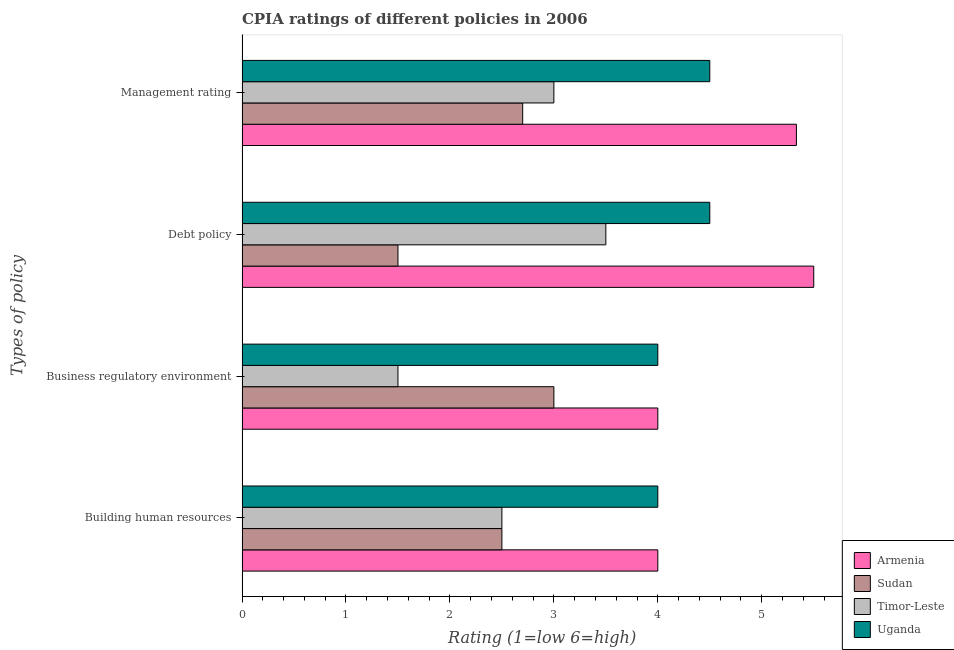How many different coloured bars are there?
Your answer should be very brief. 4. How many groups of bars are there?
Provide a succinct answer. 4. How many bars are there on the 1st tick from the top?
Offer a very short reply. 4. How many bars are there on the 1st tick from the bottom?
Give a very brief answer. 4. What is the label of the 4th group of bars from the top?
Offer a terse response. Building human resources. In which country was the cpia rating of debt policy maximum?
Ensure brevity in your answer.  Armenia. In which country was the cpia rating of building human resources minimum?
Your answer should be very brief. Sudan. What is the total cpia rating of debt policy in the graph?
Your response must be concise. 15. What is the difference between the cpia rating of management in Sudan and that in Uganda?
Your response must be concise. -1.8. What is the difference between the cpia rating of building human resources in Armenia and the cpia rating of business regulatory environment in Uganda?
Your answer should be compact. 0. What is the average cpia rating of debt policy per country?
Make the answer very short. 3.75. What is the difference between the cpia rating of debt policy and cpia rating of business regulatory environment in Armenia?
Offer a very short reply. 1.5. In how many countries, is the cpia rating of management greater than 2 ?
Provide a succinct answer. 4. What is the ratio of the cpia rating of debt policy in Uganda to that in Armenia?
Provide a short and direct response. 0.82. Is the difference between the cpia rating of management in Uganda and Sudan greater than the difference between the cpia rating of building human resources in Uganda and Sudan?
Make the answer very short. Yes. What is the difference between the highest and the second highest cpia rating of business regulatory environment?
Your answer should be very brief. 0. What is the difference between the highest and the lowest cpia rating of management?
Your response must be concise. 2.63. In how many countries, is the cpia rating of management greater than the average cpia rating of management taken over all countries?
Offer a very short reply. 2. What does the 4th bar from the top in Business regulatory environment represents?
Make the answer very short. Armenia. What does the 1st bar from the bottom in Debt policy represents?
Offer a very short reply. Armenia. Is it the case that in every country, the sum of the cpia rating of building human resources and cpia rating of business regulatory environment is greater than the cpia rating of debt policy?
Provide a succinct answer. Yes. How many bars are there?
Ensure brevity in your answer.  16. Are all the bars in the graph horizontal?
Provide a short and direct response. Yes. Does the graph contain grids?
Keep it short and to the point. No. Where does the legend appear in the graph?
Provide a succinct answer. Bottom right. What is the title of the graph?
Ensure brevity in your answer.  CPIA ratings of different policies in 2006. What is the label or title of the Y-axis?
Your answer should be compact. Types of policy. What is the Rating (1=low 6=high) in Sudan in Building human resources?
Provide a succinct answer. 2.5. What is the Rating (1=low 6=high) in Timor-Leste in Building human resources?
Give a very brief answer. 2.5. What is the Rating (1=low 6=high) of Armenia in Debt policy?
Make the answer very short. 5.5. What is the Rating (1=low 6=high) in Timor-Leste in Debt policy?
Make the answer very short. 3.5. What is the Rating (1=low 6=high) of Uganda in Debt policy?
Provide a succinct answer. 4.5. What is the Rating (1=low 6=high) in Armenia in Management rating?
Provide a short and direct response. 5.33. What is the Rating (1=low 6=high) in Sudan in Management rating?
Make the answer very short. 2.7. What is the Rating (1=low 6=high) in Uganda in Management rating?
Your answer should be very brief. 4.5. Across all Types of policy, what is the maximum Rating (1=low 6=high) in Sudan?
Your response must be concise. 3. Across all Types of policy, what is the maximum Rating (1=low 6=high) of Uganda?
Offer a very short reply. 4.5. Across all Types of policy, what is the minimum Rating (1=low 6=high) in Sudan?
Offer a very short reply. 1.5. What is the total Rating (1=low 6=high) in Armenia in the graph?
Your answer should be very brief. 18.83. What is the total Rating (1=low 6=high) of Uganda in the graph?
Offer a very short reply. 17. What is the difference between the Rating (1=low 6=high) of Armenia in Building human resources and that in Business regulatory environment?
Keep it short and to the point. 0. What is the difference between the Rating (1=low 6=high) of Sudan in Building human resources and that in Business regulatory environment?
Your answer should be compact. -0.5. What is the difference between the Rating (1=low 6=high) of Timor-Leste in Building human resources and that in Business regulatory environment?
Make the answer very short. 1. What is the difference between the Rating (1=low 6=high) of Uganda in Building human resources and that in Business regulatory environment?
Offer a very short reply. 0. What is the difference between the Rating (1=low 6=high) of Sudan in Building human resources and that in Debt policy?
Ensure brevity in your answer.  1. What is the difference between the Rating (1=low 6=high) in Timor-Leste in Building human resources and that in Debt policy?
Offer a terse response. -1. What is the difference between the Rating (1=low 6=high) in Uganda in Building human resources and that in Debt policy?
Give a very brief answer. -0.5. What is the difference between the Rating (1=low 6=high) of Armenia in Building human resources and that in Management rating?
Provide a succinct answer. -1.33. What is the difference between the Rating (1=low 6=high) in Sudan in Building human resources and that in Management rating?
Provide a short and direct response. -0.2. What is the difference between the Rating (1=low 6=high) of Timor-Leste in Building human resources and that in Management rating?
Keep it short and to the point. -0.5. What is the difference between the Rating (1=low 6=high) in Armenia in Business regulatory environment and that in Debt policy?
Offer a terse response. -1.5. What is the difference between the Rating (1=low 6=high) of Timor-Leste in Business regulatory environment and that in Debt policy?
Ensure brevity in your answer.  -2. What is the difference between the Rating (1=low 6=high) of Uganda in Business regulatory environment and that in Debt policy?
Give a very brief answer. -0.5. What is the difference between the Rating (1=low 6=high) in Armenia in Business regulatory environment and that in Management rating?
Your response must be concise. -1.33. What is the difference between the Rating (1=low 6=high) of Timor-Leste in Business regulatory environment and that in Management rating?
Keep it short and to the point. -1.5. What is the difference between the Rating (1=low 6=high) of Uganda in Business regulatory environment and that in Management rating?
Give a very brief answer. -0.5. What is the difference between the Rating (1=low 6=high) of Armenia in Debt policy and that in Management rating?
Offer a very short reply. 0.17. What is the difference between the Rating (1=low 6=high) in Uganda in Debt policy and that in Management rating?
Give a very brief answer. 0. What is the difference between the Rating (1=low 6=high) in Armenia in Building human resources and the Rating (1=low 6=high) in Uganda in Business regulatory environment?
Offer a terse response. 0. What is the difference between the Rating (1=low 6=high) in Sudan in Building human resources and the Rating (1=low 6=high) in Timor-Leste in Business regulatory environment?
Give a very brief answer. 1. What is the difference between the Rating (1=low 6=high) of Sudan in Building human resources and the Rating (1=low 6=high) of Uganda in Business regulatory environment?
Provide a short and direct response. -1.5. What is the difference between the Rating (1=low 6=high) in Timor-Leste in Building human resources and the Rating (1=low 6=high) in Uganda in Business regulatory environment?
Your answer should be very brief. -1.5. What is the difference between the Rating (1=low 6=high) of Armenia in Building human resources and the Rating (1=low 6=high) of Sudan in Debt policy?
Offer a terse response. 2.5. What is the difference between the Rating (1=low 6=high) of Armenia in Building human resources and the Rating (1=low 6=high) of Timor-Leste in Management rating?
Offer a terse response. 1. What is the difference between the Rating (1=low 6=high) in Armenia in Building human resources and the Rating (1=low 6=high) in Uganda in Management rating?
Offer a terse response. -0.5. What is the difference between the Rating (1=low 6=high) of Sudan in Building human resources and the Rating (1=low 6=high) of Timor-Leste in Management rating?
Make the answer very short. -0.5. What is the difference between the Rating (1=low 6=high) in Sudan in Building human resources and the Rating (1=low 6=high) in Uganda in Management rating?
Ensure brevity in your answer.  -2. What is the difference between the Rating (1=low 6=high) in Timor-Leste in Building human resources and the Rating (1=low 6=high) in Uganda in Management rating?
Make the answer very short. -2. What is the difference between the Rating (1=low 6=high) of Armenia in Business regulatory environment and the Rating (1=low 6=high) of Uganda in Debt policy?
Offer a very short reply. -0.5. What is the difference between the Rating (1=low 6=high) in Sudan in Business regulatory environment and the Rating (1=low 6=high) in Uganda in Debt policy?
Keep it short and to the point. -1.5. What is the difference between the Rating (1=low 6=high) in Timor-Leste in Business regulatory environment and the Rating (1=low 6=high) in Uganda in Debt policy?
Your answer should be very brief. -3. What is the difference between the Rating (1=low 6=high) of Sudan in Business regulatory environment and the Rating (1=low 6=high) of Timor-Leste in Management rating?
Your answer should be compact. 0. What is the difference between the Rating (1=low 6=high) of Sudan in Business regulatory environment and the Rating (1=low 6=high) of Uganda in Management rating?
Ensure brevity in your answer.  -1.5. What is the difference between the Rating (1=low 6=high) in Armenia in Debt policy and the Rating (1=low 6=high) in Sudan in Management rating?
Keep it short and to the point. 2.8. What is the difference between the Rating (1=low 6=high) of Armenia in Debt policy and the Rating (1=low 6=high) of Timor-Leste in Management rating?
Your response must be concise. 2.5. What is the difference between the Rating (1=low 6=high) in Timor-Leste in Debt policy and the Rating (1=low 6=high) in Uganda in Management rating?
Keep it short and to the point. -1. What is the average Rating (1=low 6=high) in Armenia per Types of policy?
Your response must be concise. 4.71. What is the average Rating (1=low 6=high) of Sudan per Types of policy?
Make the answer very short. 2.42. What is the average Rating (1=low 6=high) in Timor-Leste per Types of policy?
Offer a very short reply. 2.62. What is the average Rating (1=low 6=high) of Uganda per Types of policy?
Provide a succinct answer. 4.25. What is the difference between the Rating (1=low 6=high) of Armenia and Rating (1=low 6=high) of Sudan in Building human resources?
Make the answer very short. 1.5. What is the difference between the Rating (1=low 6=high) in Armenia and Rating (1=low 6=high) in Uganda in Building human resources?
Ensure brevity in your answer.  0. What is the difference between the Rating (1=low 6=high) of Sudan and Rating (1=low 6=high) of Uganda in Building human resources?
Offer a terse response. -1.5. What is the difference between the Rating (1=low 6=high) of Armenia and Rating (1=low 6=high) of Sudan in Business regulatory environment?
Your answer should be compact. 1. What is the difference between the Rating (1=low 6=high) in Armenia and Rating (1=low 6=high) in Uganda in Business regulatory environment?
Give a very brief answer. 0. What is the difference between the Rating (1=low 6=high) of Sudan and Rating (1=low 6=high) of Timor-Leste in Business regulatory environment?
Offer a very short reply. 1.5. What is the difference between the Rating (1=low 6=high) in Timor-Leste and Rating (1=low 6=high) in Uganda in Business regulatory environment?
Ensure brevity in your answer.  -2.5. What is the difference between the Rating (1=low 6=high) of Armenia and Rating (1=low 6=high) of Sudan in Debt policy?
Keep it short and to the point. 4. What is the difference between the Rating (1=low 6=high) of Armenia and Rating (1=low 6=high) of Timor-Leste in Debt policy?
Your answer should be compact. 2. What is the difference between the Rating (1=low 6=high) in Sudan and Rating (1=low 6=high) in Timor-Leste in Debt policy?
Your answer should be compact. -2. What is the difference between the Rating (1=low 6=high) in Sudan and Rating (1=low 6=high) in Uganda in Debt policy?
Offer a terse response. -3. What is the difference between the Rating (1=low 6=high) of Armenia and Rating (1=low 6=high) of Sudan in Management rating?
Ensure brevity in your answer.  2.63. What is the difference between the Rating (1=low 6=high) of Armenia and Rating (1=low 6=high) of Timor-Leste in Management rating?
Keep it short and to the point. 2.33. What is the difference between the Rating (1=low 6=high) of Armenia and Rating (1=low 6=high) of Uganda in Management rating?
Your answer should be compact. 0.83. What is the difference between the Rating (1=low 6=high) in Sudan and Rating (1=low 6=high) in Uganda in Management rating?
Ensure brevity in your answer.  -1.8. What is the ratio of the Rating (1=low 6=high) in Sudan in Building human resources to that in Business regulatory environment?
Give a very brief answer. 0.83. What is the ratio of the Rating (1=low 6=high) of Timor-Leste in Building human resources to that in Business regulatory environment?
Your response must be concise. 1.67. What is the ratio of the Rating (1=low 6=high) in Armenia in Building human resources to that in Debt policy?
Give a very brief answer. 0.73. What is the ratio of the Rating (1=low 6=high) of Sudan in Building human resources to that in Debt policy?
Your answer should be compact. 1.67. What is the ratio of the Rating (1=low 6=high) in Timor-Leste in Building human resources to that in Debt policy?
Provide a succinct answer. 0.71. What is the ratio of the Rating (1=low 6=high) in Uganda in Building human resources to that in Debt policy?
Your answer should be very brief. 0.89. What is the ratio of the Rating (1=low 6=high) of Armenia in Building human resources to that in Management rating?
Your response must be concise. 0.75. What is the ratio of the Rating (1=low 6=high) in Sudan in Building human resources to that in Management rating?
Provide a succinct answer. 0.93. What is the ratio of the Rating (1=low 6=high) of Timor-Leste in Building human resources to that in Management rating?
Keep it short and to the point. 0.83. What is the ratio of the Rating (1=low 6=high) of Armenia in Business regulatory environment to that in Debt policy?
Your answer should be compact. 0.73. What is the ratio of the Rating (1=low 6=high) of Sudan in Business regulatory environment to that in Debt policy?
Give a very brief answer. 2. What is the ratio of the Rating (1=low 6=high) of Timor-Leste in Business regulatory environment to that in Debt policy?
Your response must be concise. 0.43. What is the ratio of the Rating (1=low 6=high) of Uganda in Business regulatory environment to that in Debt policy?
Provide a succinct answer. 0.89. What is the ratio of the Rating (1=low 6=high) of Sudan in Business regulatory environment to that in Management rating?
Your answer should be compact. 1.11. What is the ratio of the Rating (1=low 6=high) of Timor-Leste in Business regulatory environment to that in Management rating?
Ensure brevity in your answer.  0.5. What is the ratio of the Rating (1=low 6=high) of Uganda in Business regulatory environment to that in Management rating?
Make the answer very short. 0.89. What is the ratio of the Rating (1=low 6=high) in Armenia in Debt policy to that in Management rating?
Offer a very short reply. 1.03. What is the ratio of the Rating (1=low 6=high) in Sudan in Debt policy to that in Management rating?
Provide a succinct answer. 0.56. What is the difference between the highest and the second highest Rating (1=low 6=high) of Armenia?
Your answer should be very brief. 0.17. What is the difference between the highest and the second highest Rating (1=low 6=high) of Sudan?
Provide a succinct answer. 0.3. 